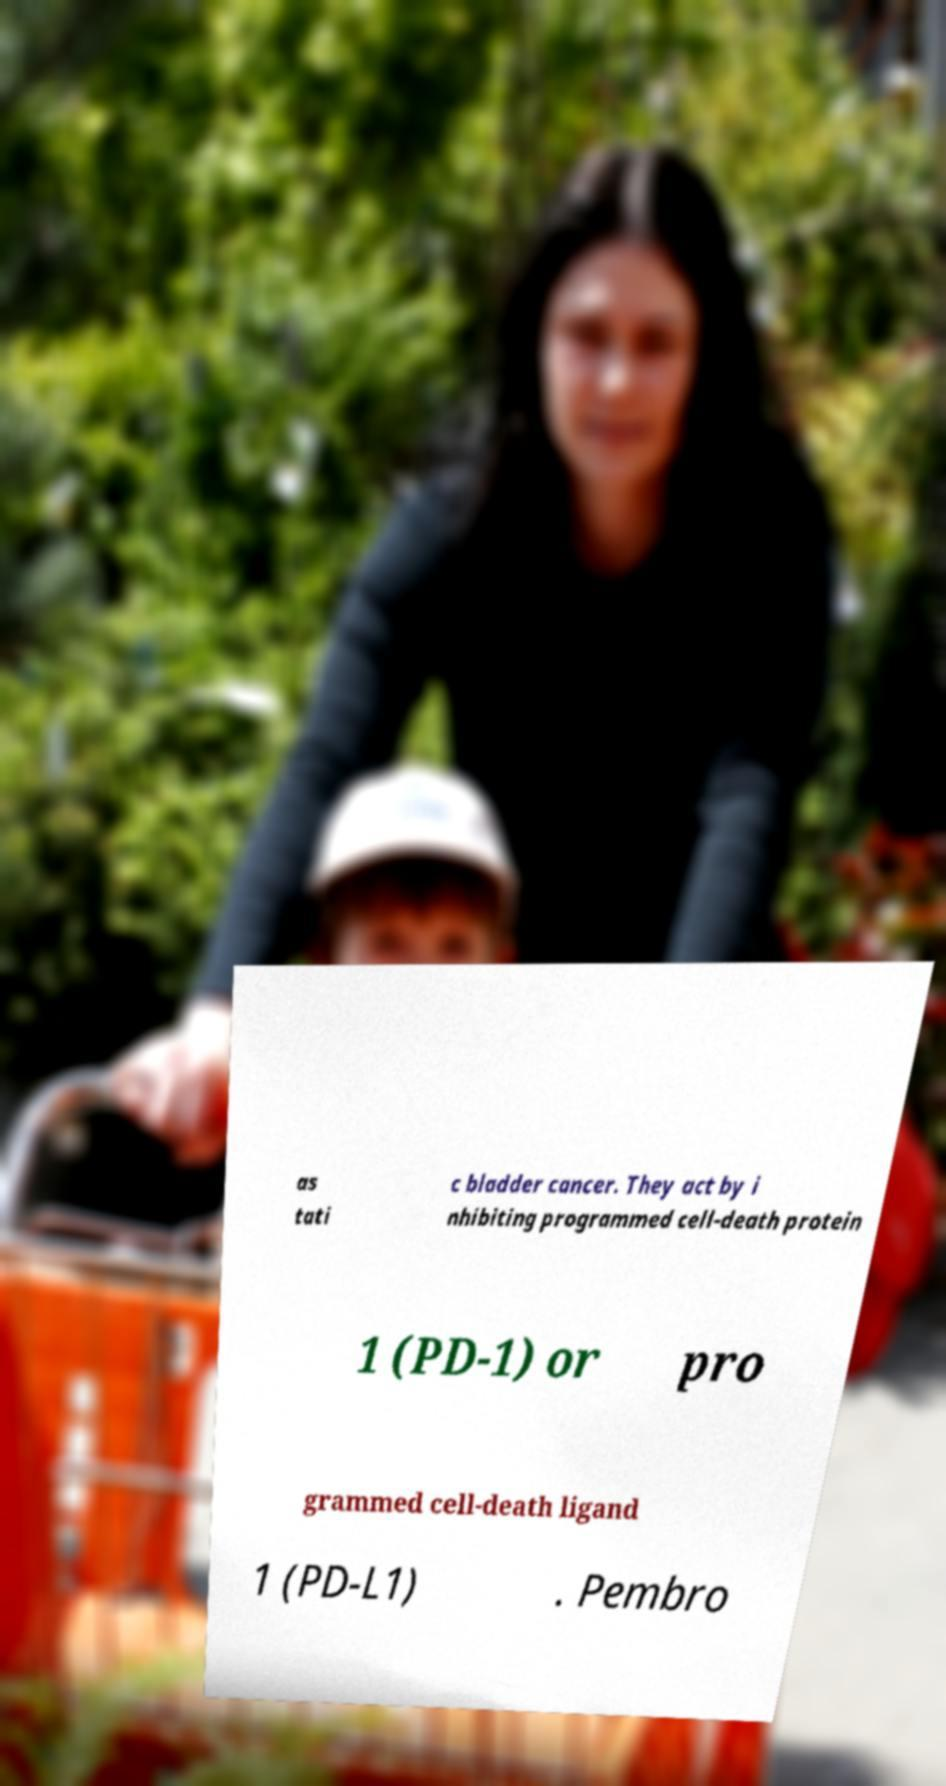Please read and relay the text visible in this image. What does it say? as tati c bladder cancer. They act by i nhibiting programmed cell-death protein 1 (PD-1) or pro grammed cell-death ligand 1 (PD-L1) . Pembro 